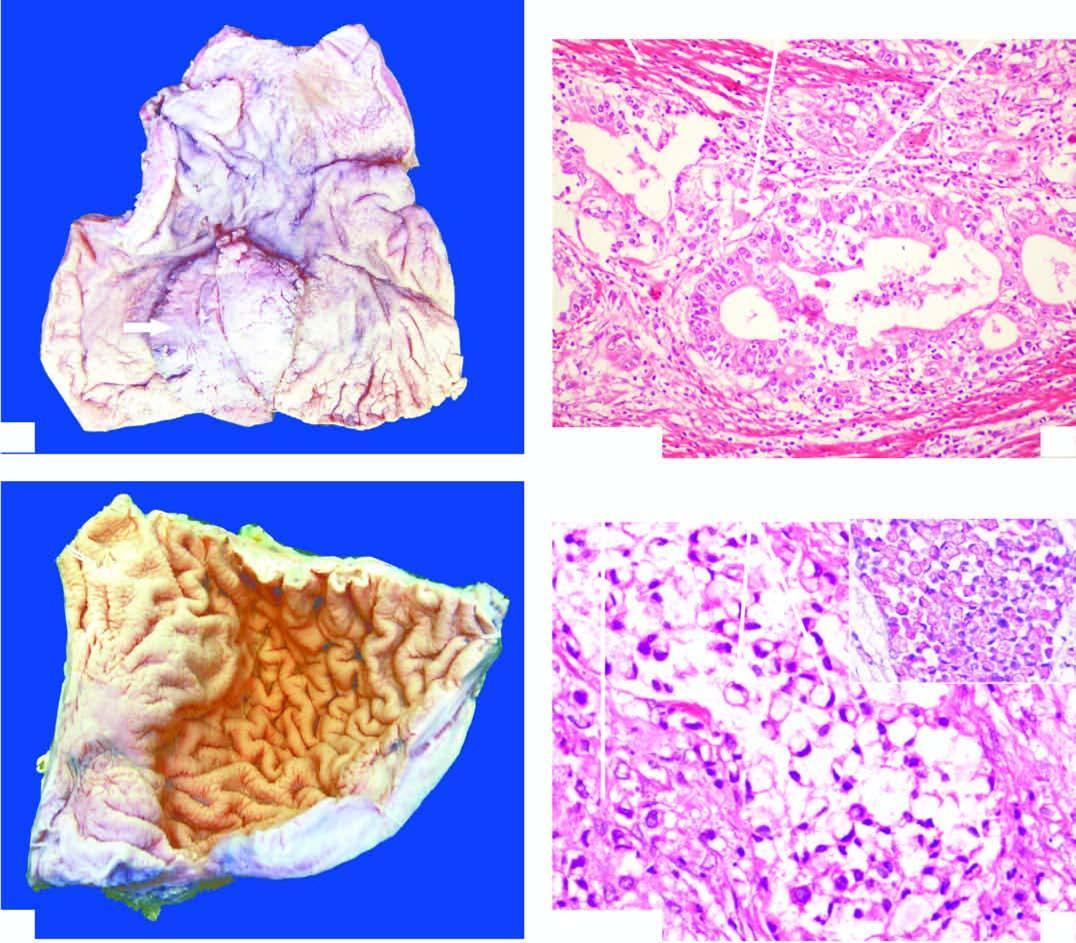s line of demarcation between gangrenous segment and the viable bowel desmoplastic?
Answer the question using a single word or phrase. No 